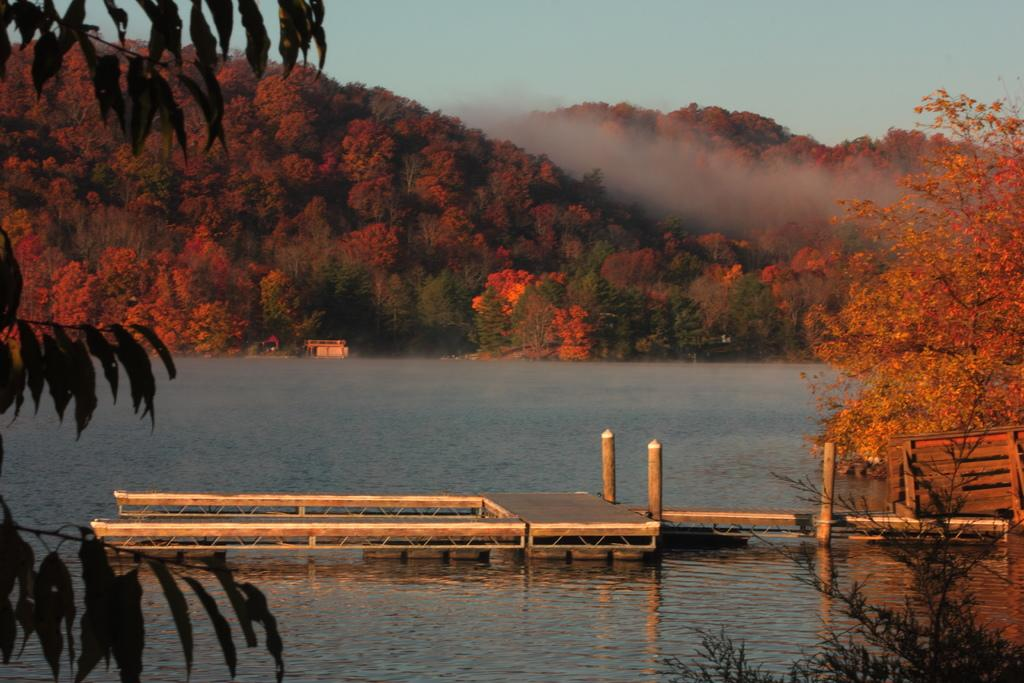What type of natural elements can be seen in the image? There are trees and water visible in the image. What is the weather condition in the image? There is fog in the image, which suggests a cool or damp environment. What man-made structure is present in the image? There is a bridge in the image. What part of the natural environment is visible in the image? The sky is visible in the image. What type of knee support is visible in the image? There is no knee support present in the image. What type of school can be seen in the image? There is no school present in the image. 